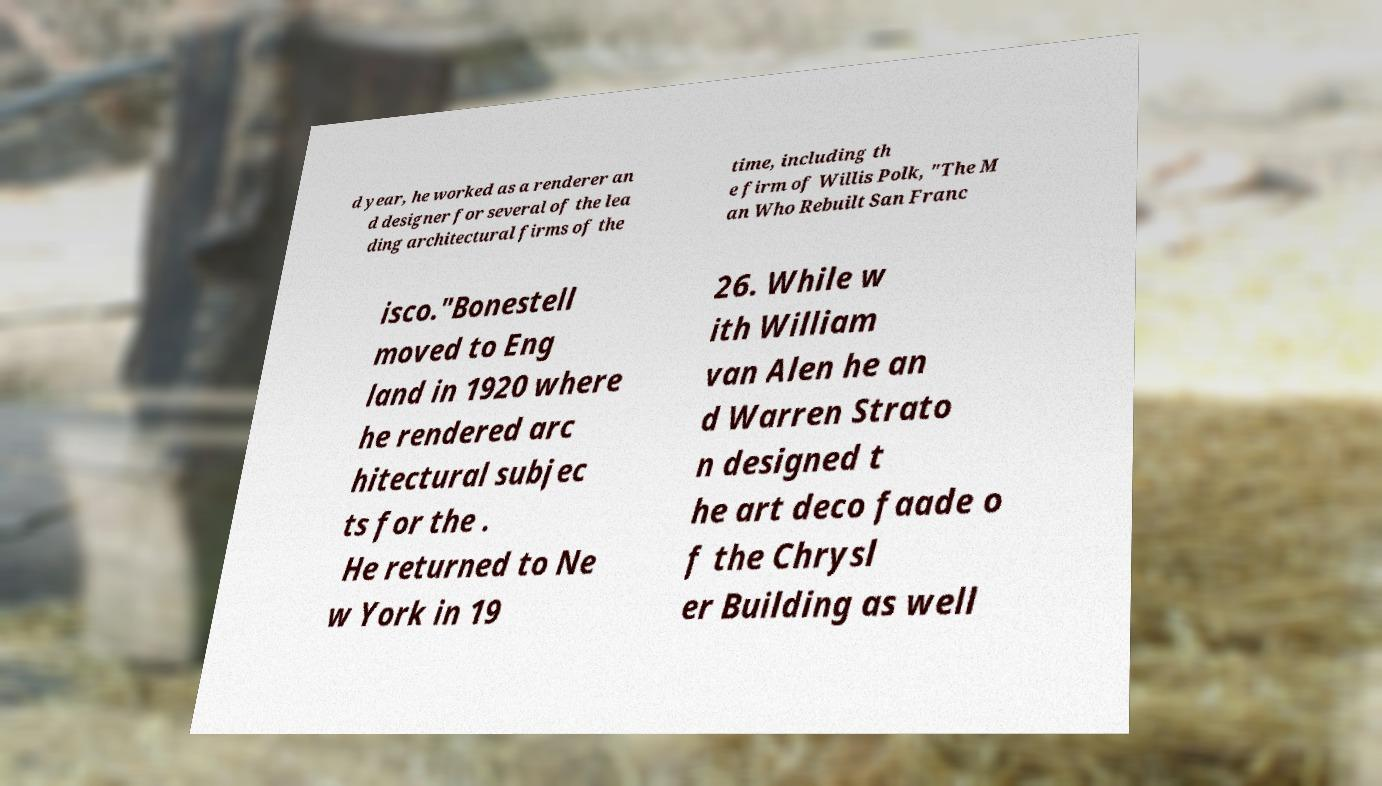Please read and relay the text visible in this image. What does it say? d year, he worked as a renderer an d designer for several of the lea ding architectural firms of the time, including th e firm of Willis Polk, "The M an Who Rebuilt San Franc isco."Bonestell moved to Eng land in 1920 where he rendered arc hitectural subjec ts for the . He returned to Ne w York in 19 26. While w ith William van Alen he an d Warren Strato n designed t he art deco faade o f the Chrysl er Building as well 